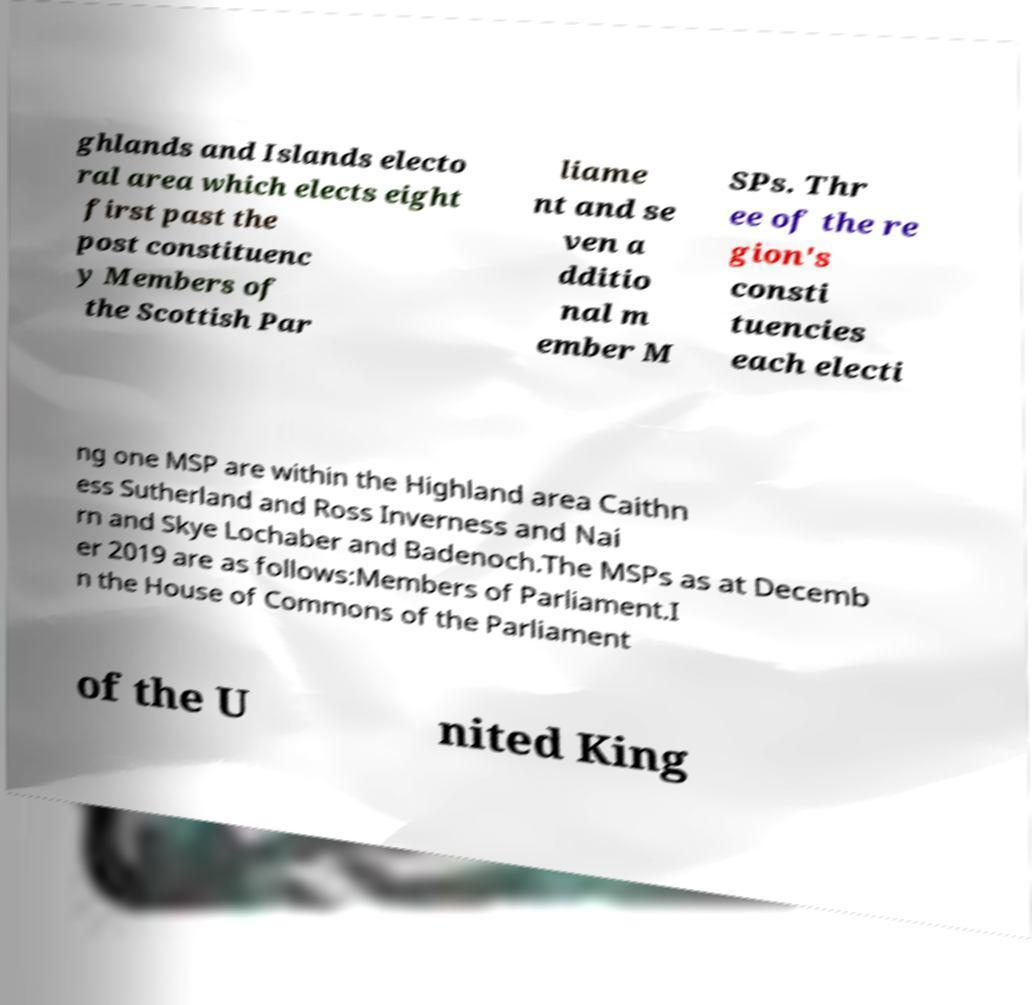For documentation purposes, I need the text within this image transcribed. Could you provide that? ghlands and Islands electo ral area which elects eight first past the post constituenc y Members of the Scottish Par liame nt and se ven a dditio nal m ember M SPs. Thr ee of the re gion's consti tuencies each electi ng one MSP are within the Highland area Caithn ess Sutherland and Ross Inverness and Nai rn and Skye Lochaber and Badenoch.The MSPs as at Decemb er 2019 are as follows:Members of Parliament.I n the House of Commons of the Parliament of the U nited King 